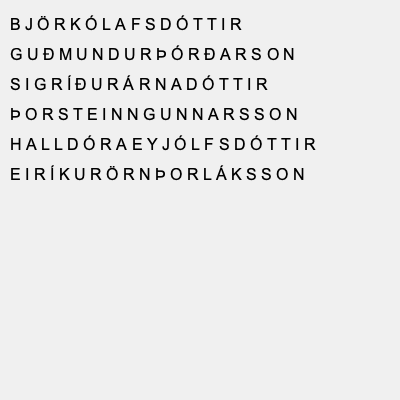In the Icelandic name word search above, identify the correctly spelled name that follows the patronymic naming tradition and contains the special character "Ð" (eth). To solve this question, we need to follow these steps:

1. Understand the patronymic naming tradition in Iceland:
   - For males, it typically ends with "-son" (meaning "son of")
   - For females, it typically ends with "-dóttir" (meaning "daughter of")

2. Identify names that follow the patronymic tradition:
   - Björk Ólafsdóttir (female)
   - Guðmundur Þórðarson (male)
   - Sigríður Árnadóttir (female)
   - Þorsteinn Gunnarsson (male)
   - Halldóra Eyjólfsdóttir (female)
   - Eiríkur Örn Þorláksson (male)

3. Look for names containing the special character "Ð" (eth):
   - Guðmundur Þórðarson

4. Verify that the spelling is correct:
   - Guðmundur Þórðarson is correctly spelled and follows the patronymic tradition for males.

Therefore, the correctly spelled name that follows the patronymic naming tradition and contains the special character "Ð" (eth) is Guðmundur Þórðarson.
Answer: Guðmundur Þórðarson 